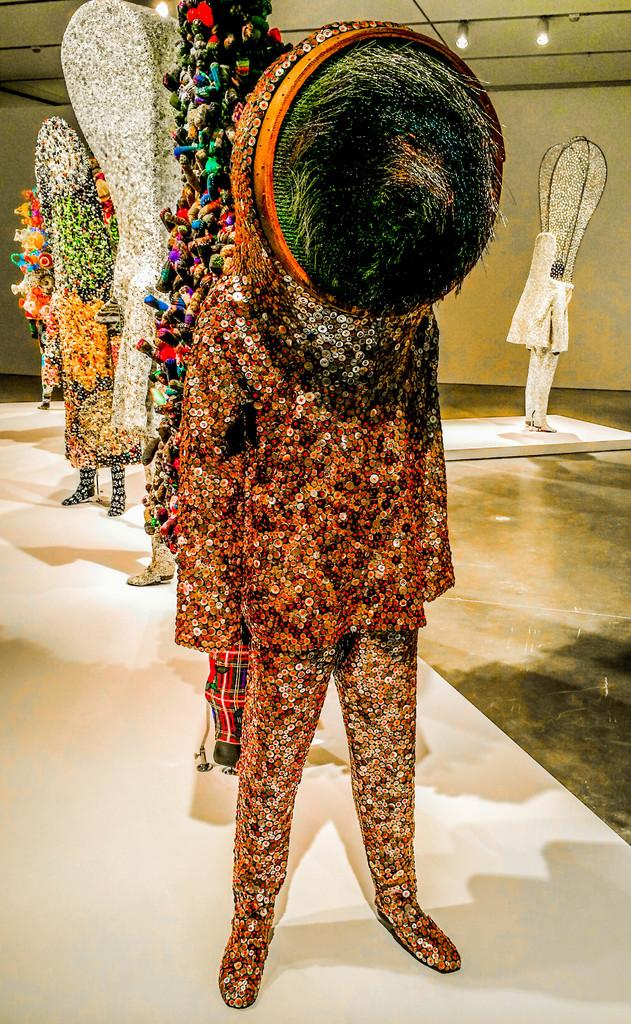What is the main structure visible in the image? There is a white platform in the image. What is placed on the platform? There are multiple statues on the platform. What direction is the train moving on the platform in the image? There is no train present in the image. How steep is the slope near the statues on the platform? There is no slope visible in the image; it only shows a white platform with statues. 